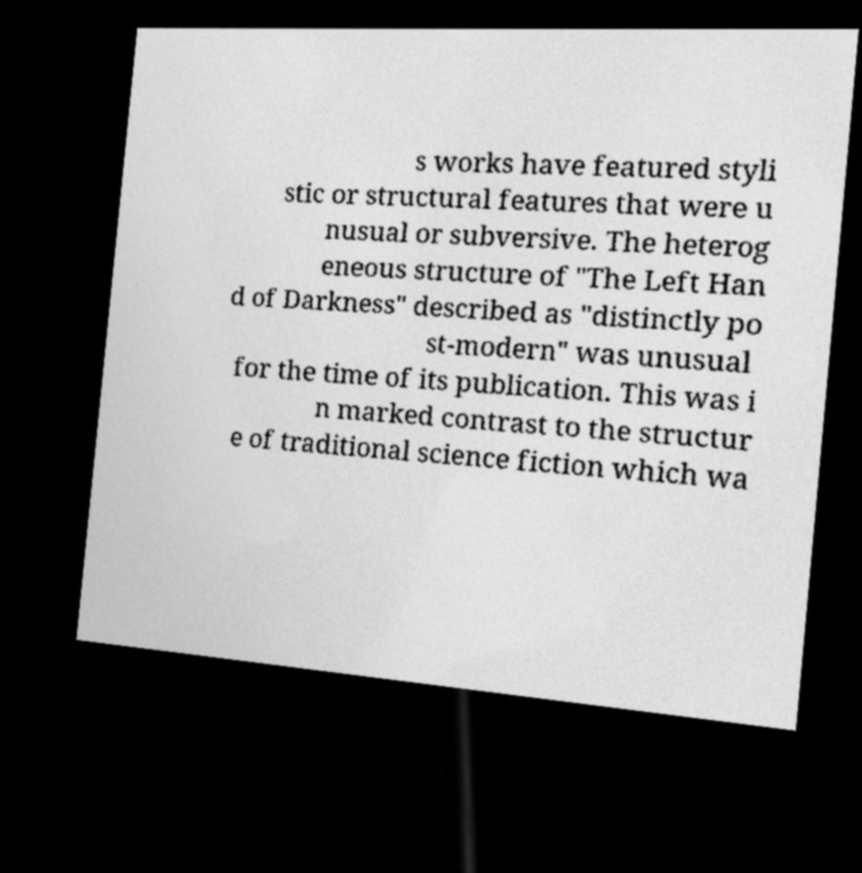Could you extract and type out the text from this image? s works have featured styli stic or structural features that were u nusual or subversive. The heterog eneous structure of "The Left Han d of Darkness" described as "distinctly po st-modern" was unusual for the time of its publication. This was i n marked contrast to the structur e of traditional science fiction which wa 